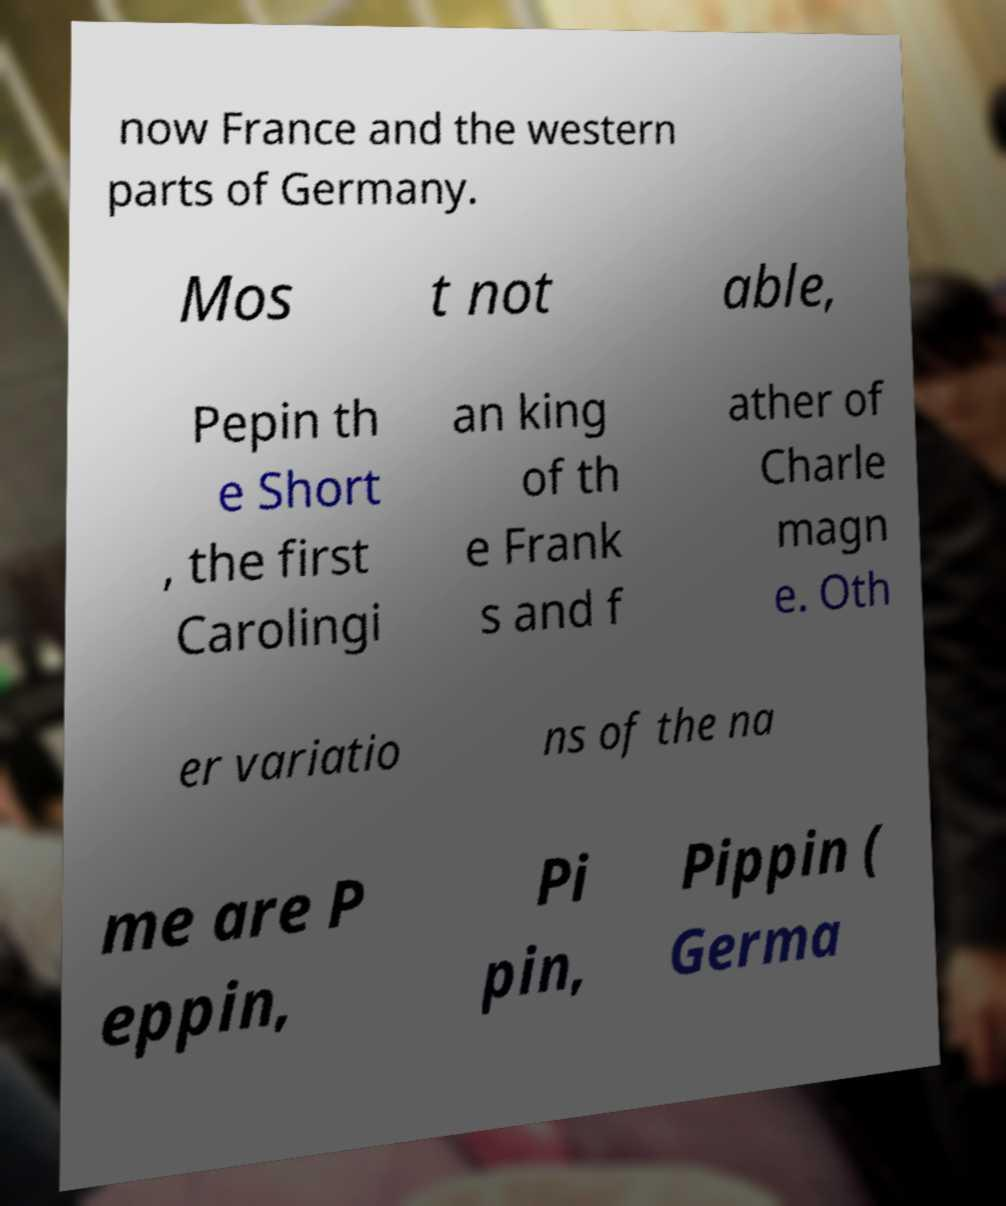I need the written content from this picture converted into text. Can you do that? now France and the western parts of Germany. Mos t not able, Pepin th e Short , the first Carolingi an king of th e Frank s and f ather of Charle magn e. Oth er variatio ns of the na me are P eppin, Pi pin, Pippin ( Germa 